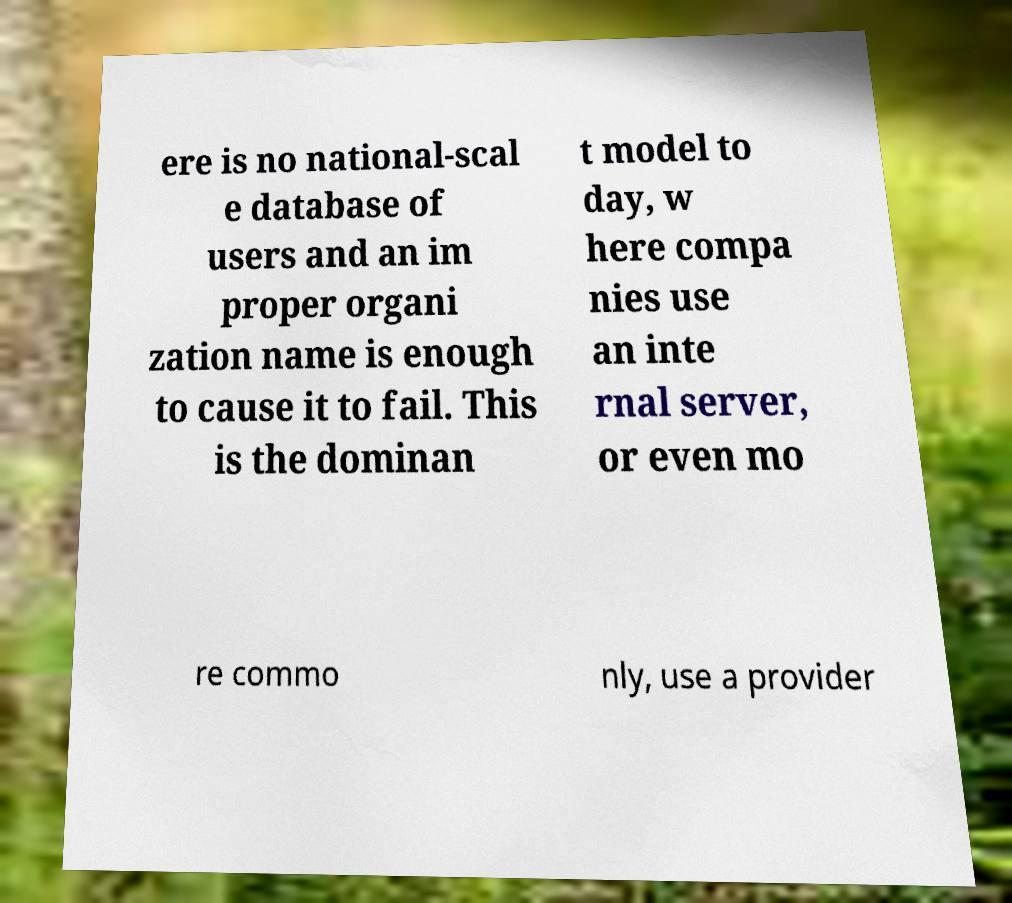Please read and relay the text visible in this image. What does it say? ere is no national-scal e database of users and an im proper organi zation name is enough to cause it to fail. This is the dominan t model to day, w here compa nies use an inte rnal server, or even mo re commo nly, use a provider 